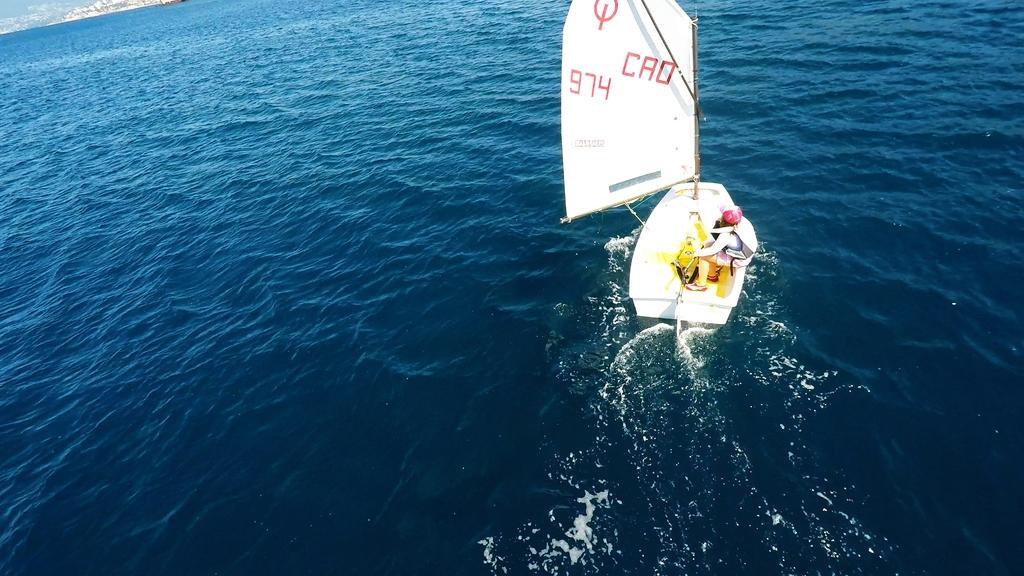How would you summarize this image in a sentence or two? There is a white boat on the water. A person is sitting on the boat. 